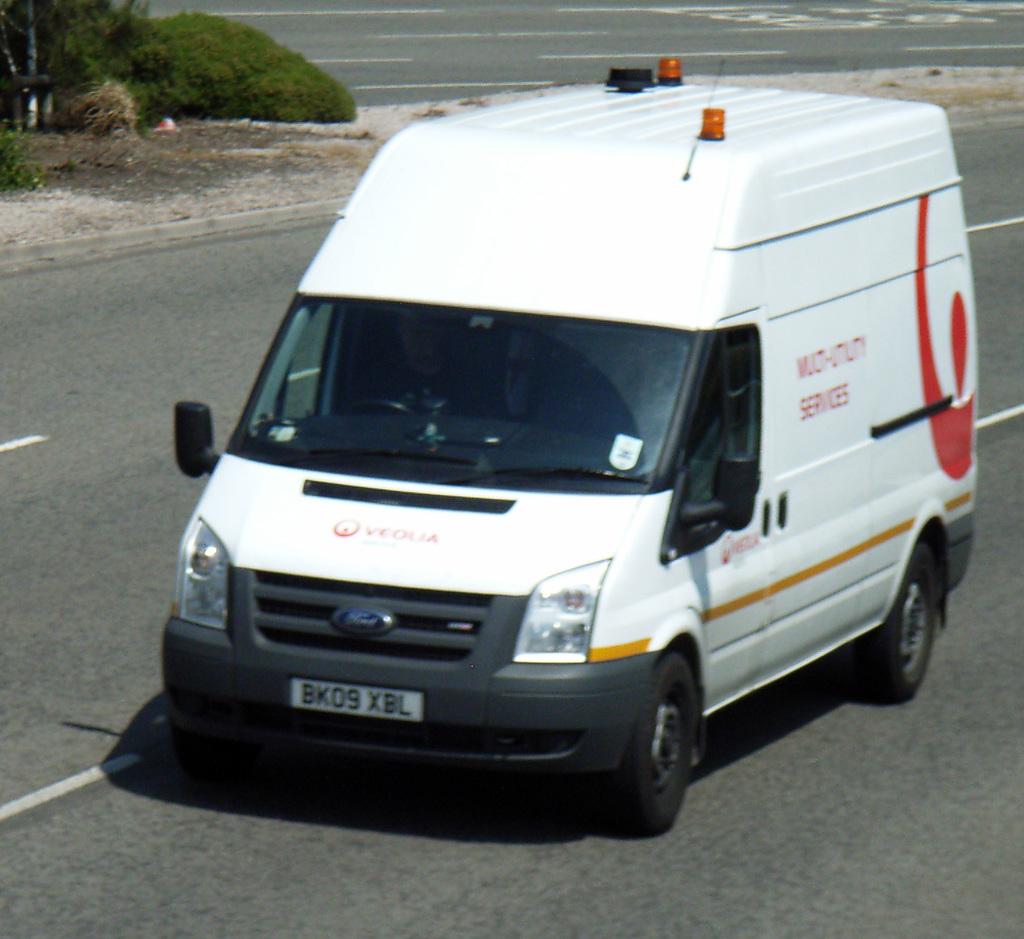What does the license plate say?
Your answer should be compact. Bk09 xbl. How many yellow lights are on the van?
Your response must be concise. Answering does not require reading text in the image. 